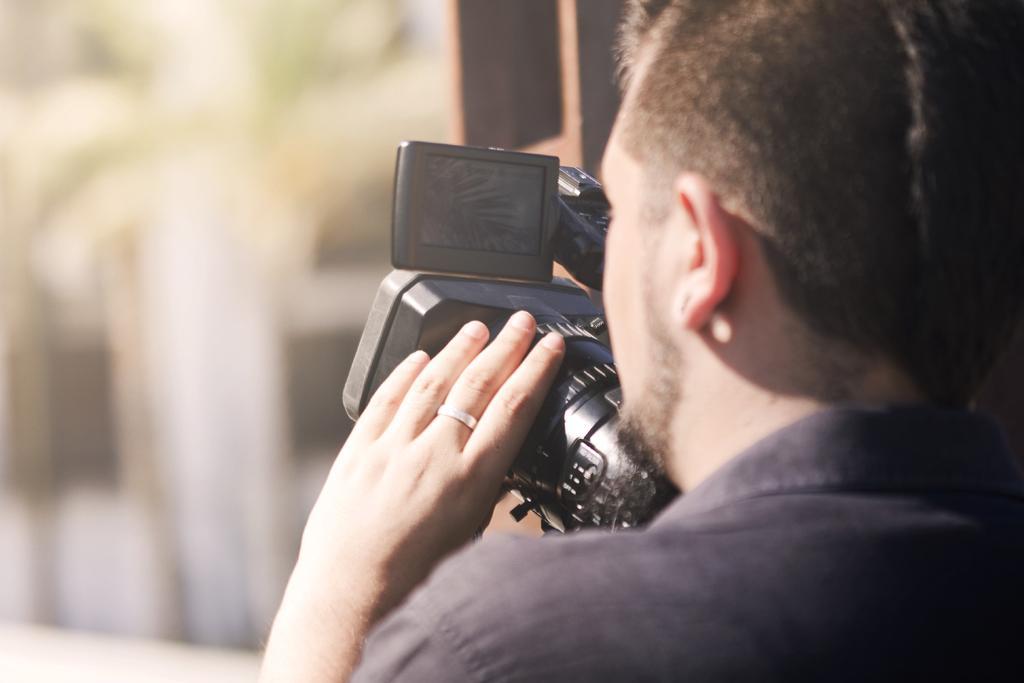Could you give a brief overview of what you see in this image? In this picture we can see a man who is holding a camera with his hand. 